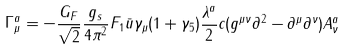<formula> <loc_0><loc_0><loc_500><loc_500>\Gamma _ { \mu } ^ { a } = - \frac { G _ { F } } { \sqrt { 2 } } \frac { g _ { s } } { 4 \pi ^ { 2 } } F _ { 1 } \bar { u } \gamma _ { \mu } ( 1 + \gamma _ { 5 } ) \frac { \lambda ^ { a } } { 2 } c ( g ^ { \mu \nu } \partial ^ { 2 } - \partial ^ { \mu } \partial ^ { \nu } ) A ^ { a } _ { \nu }</formula> 